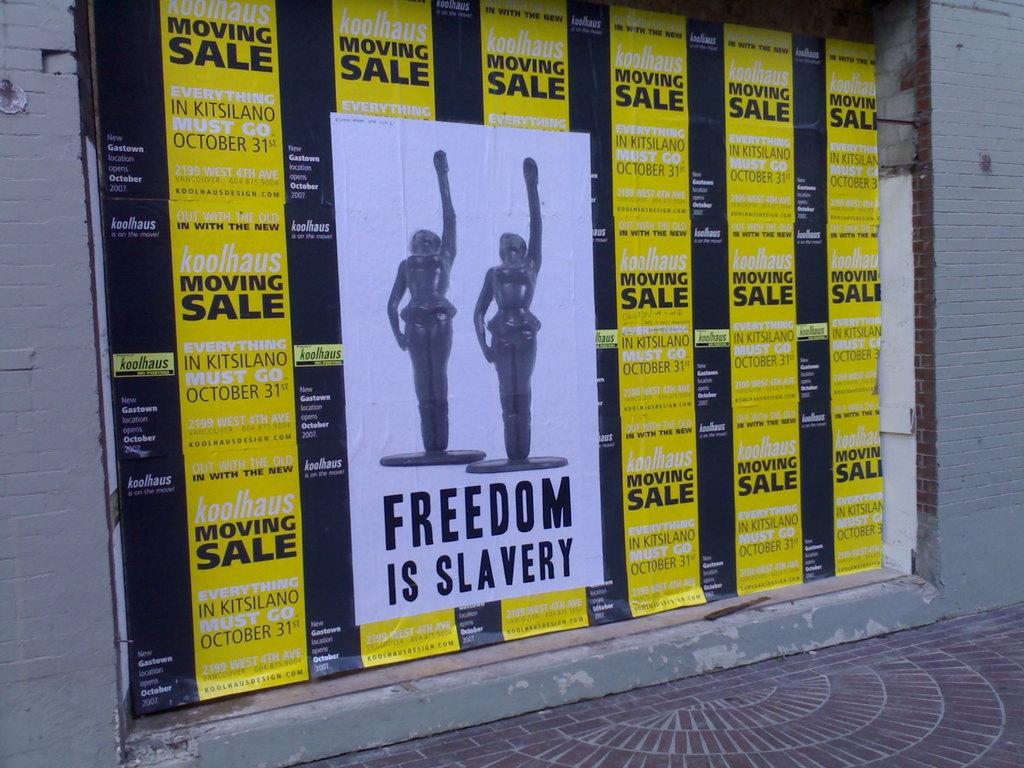<image>
Write a terse but informative summary of the picture. Moving sale advertisements are the background of a Freedom is Slavery poster. 